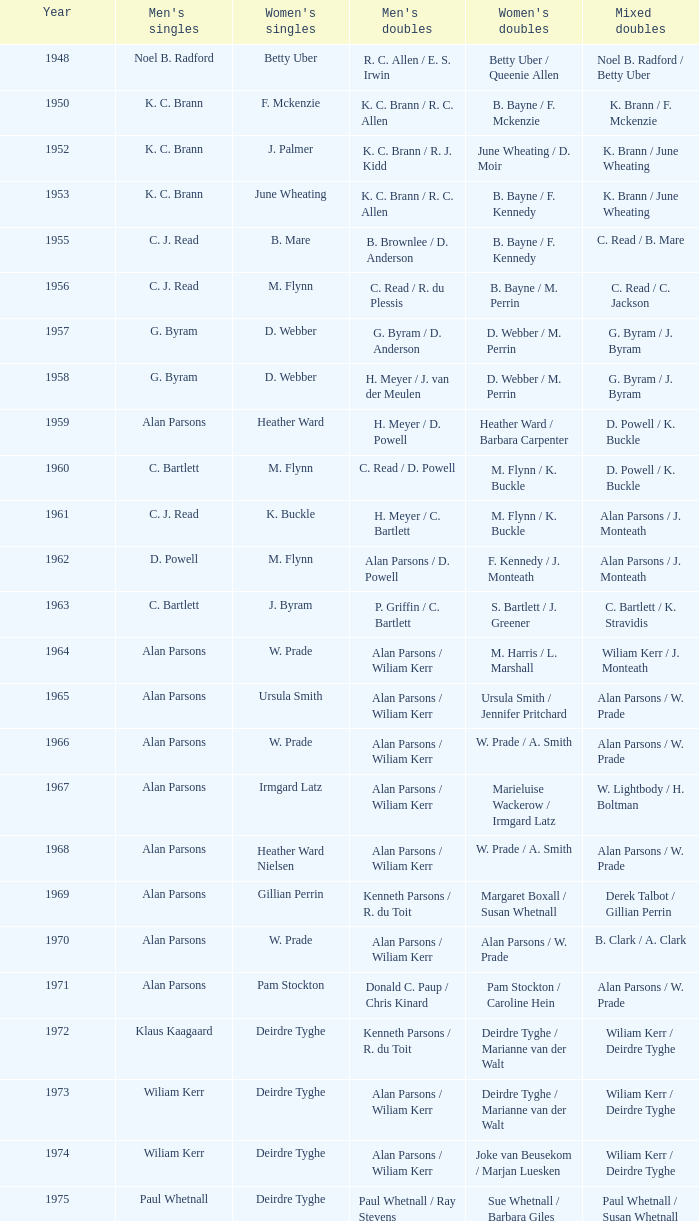Which Men's doubles have a Year smaller than 1960, and Men's singles of noel b. radford? R. C. Allen / E. S. Irwin. 